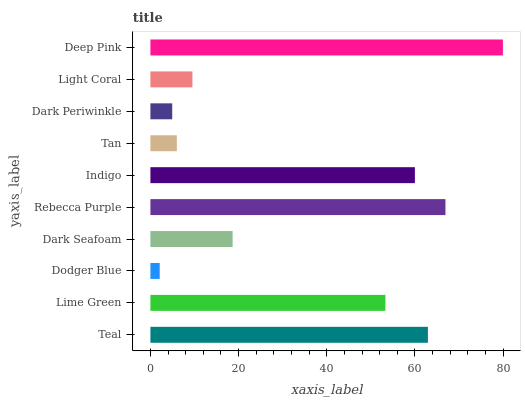Is Dodger Blue the minimum?
Answer yes or no. Yes. Is Deep Pink the maximum?
Answer yes or no. Yes. Is Lime Green the minimum?
Answer yes or no. No. Is Lime Green the maximum?
Answer yes or no. No. Is Teal greater than Lime Green?
Answer yes or no. Yes. Is Lime Green less than Teal?
Answer yes or no. Yes. Is Lime Green greater than Teal?
Answer yes or no. No. Is Teal less than Lime Green?
Answer yes or no. No. Is Lime Green the high median?
Answer yes or no. Yes. Is Dark Seafoam the low median?
Answer yes or no. Yes. Is Rebecca Purple the high median?
Answer yes or no. No. Is Lime Green the low median?
Answer yes or no. No. 